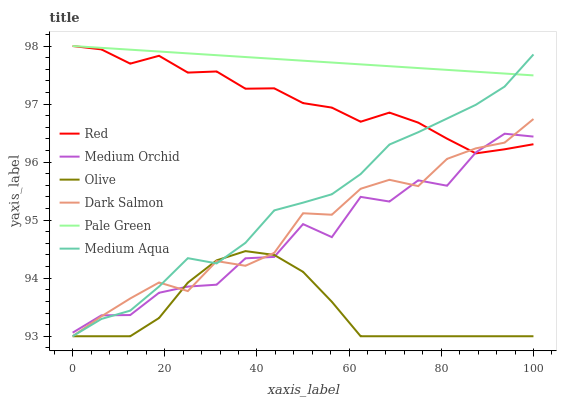Does Olive have the minimum area under the curve?
Answer yes or no. Yes. Does Pale Green have the maximum area under the curve?
Answer yes or no. Yes. Does Dark Salmon have the minimum area under the curve?
Answer yes or no. No. Does Dark Salmon have the maximum area under the curve?
Answer yes or no. No. Is Pale Green the smoothest?
Answer yes or no. Yes. Is Medium Orchid the roughest?
Answer yes or no. Yes. Is Dark Salmon the smoothest?
Answer yes or no. No. Is Dark Salmon the roughest?
Answer yes or no. No. Does Dark Salmon have the lowest value?
Answer yes or no. Yes. Does Pale Green have the lowest value?
Answer yes or no. No. Does Red have the highest value?
Answer yes or no. Yes. Does Dark Salmon have the highest value?
Answer yes or no. No. Is Olive less than Pale Green?
Answer yes or no. Yes. Is Pale Green greater than Medium Orchid?
Answer yes or no. Yes. Does Medium Aqua intersect Olive?
Answer yes or no. Yes. Is Medium Aqua less than Olive?
Answer yes or no. No. Is Medium Aqua greater than Olive?
Answer yes or no. No. Does Olive intersect Pale Green?
Answer yes or no. No. 